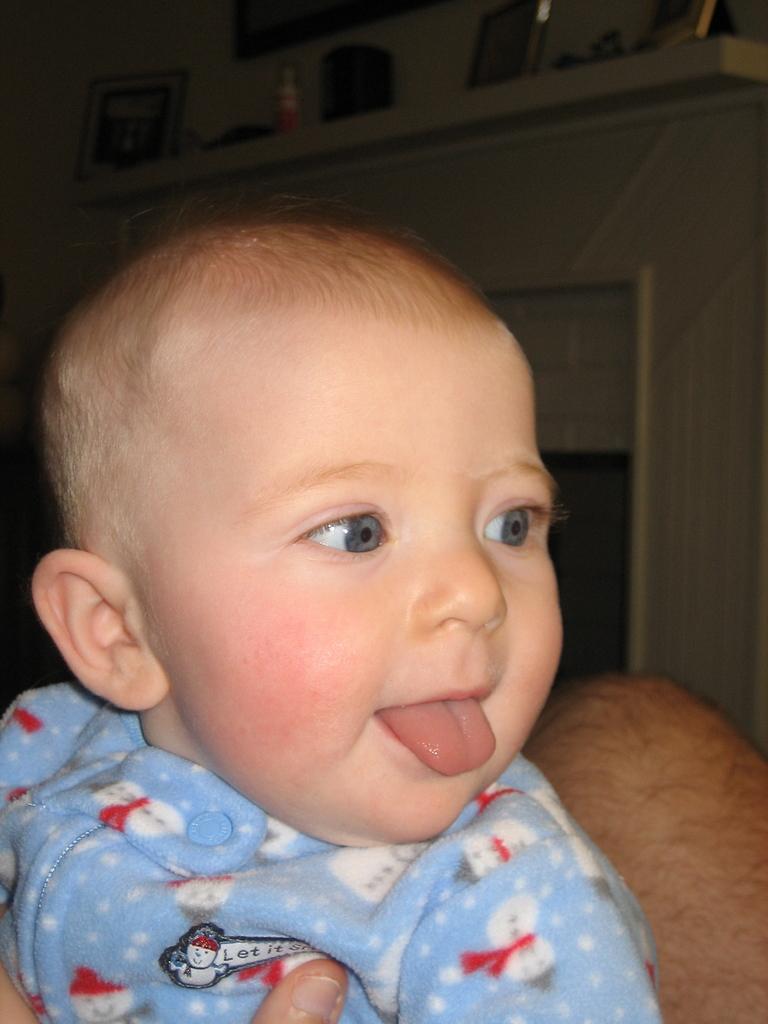In one or two sentences, can you explain what this image depicts? This is the picture of a kid who is wearing the blue, red, white shirt and behind there is a shelf in which there are some things arranged. 